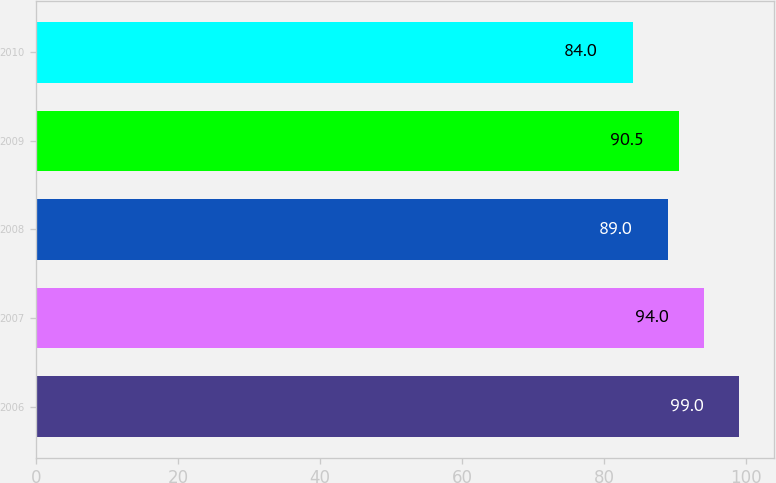Convert chart to OTSL. <chart><loc_0><loc_0><loc_500><loc_500><bar_chart><fcel>2006<fcel>2007<fcel>2008<fcel>2009<fcel>2010<nl><fcel>99<fcel>94<fcel>89<fcel>90.5<fcel>84<nl></chart> 